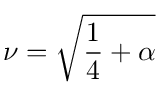Convert formula to latex. <formula><loc_0><loc_0><loc_500><loc_500>\nu = \sqrt { \frac { 1 } { 4 } + \alpha }</formula> 